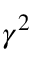<formula> <loc_0><loc_0><loc_500><loc_500>\gamma ^ { 2 }</formula> 